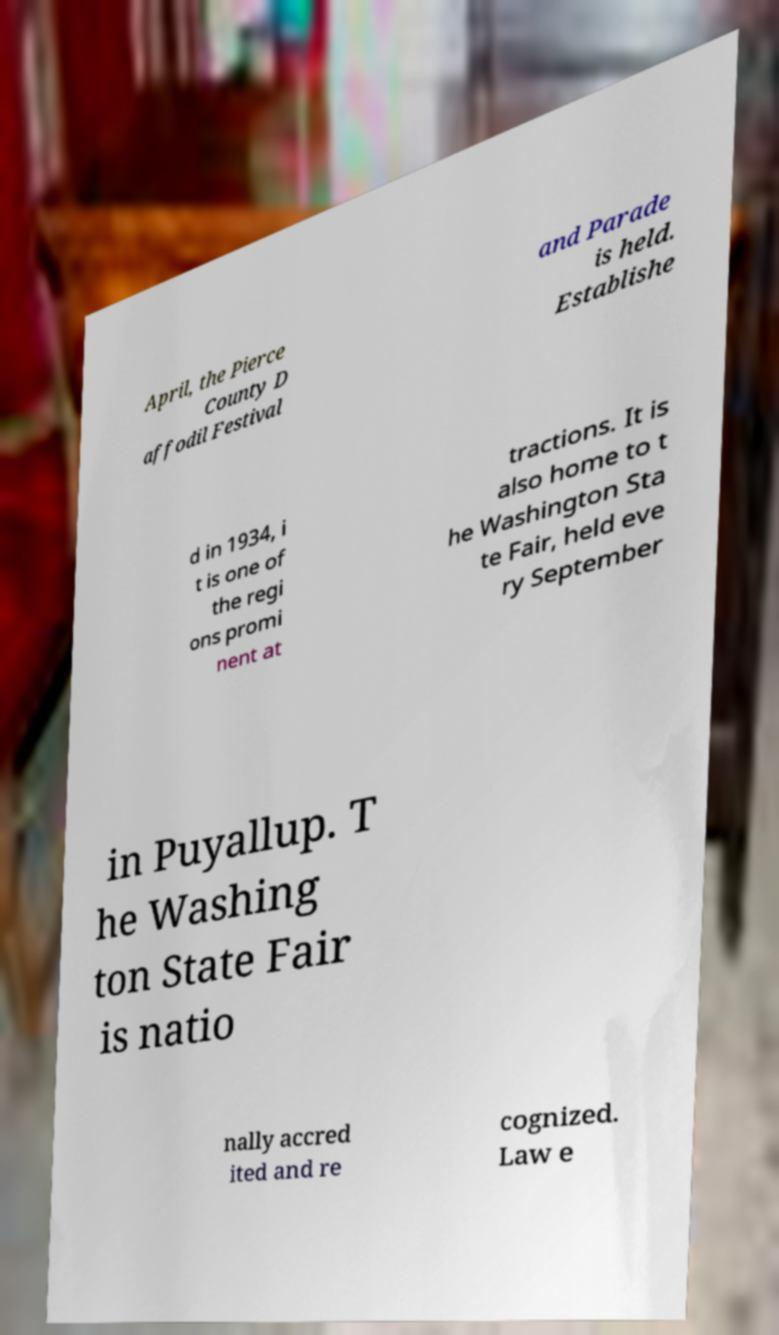I need the written content from this picture converted into text. Can you do that? April, the Pierce County D affodil Festival and Parade is held. Establishe d in 1934, i t is one of the regi ons promi nent at tractions. It is also home to t he Washington Sta te Fair, held eve ry September in Puyallup. T he Washing ton State Fair is natio nally accred ited and re cognized. Law e 